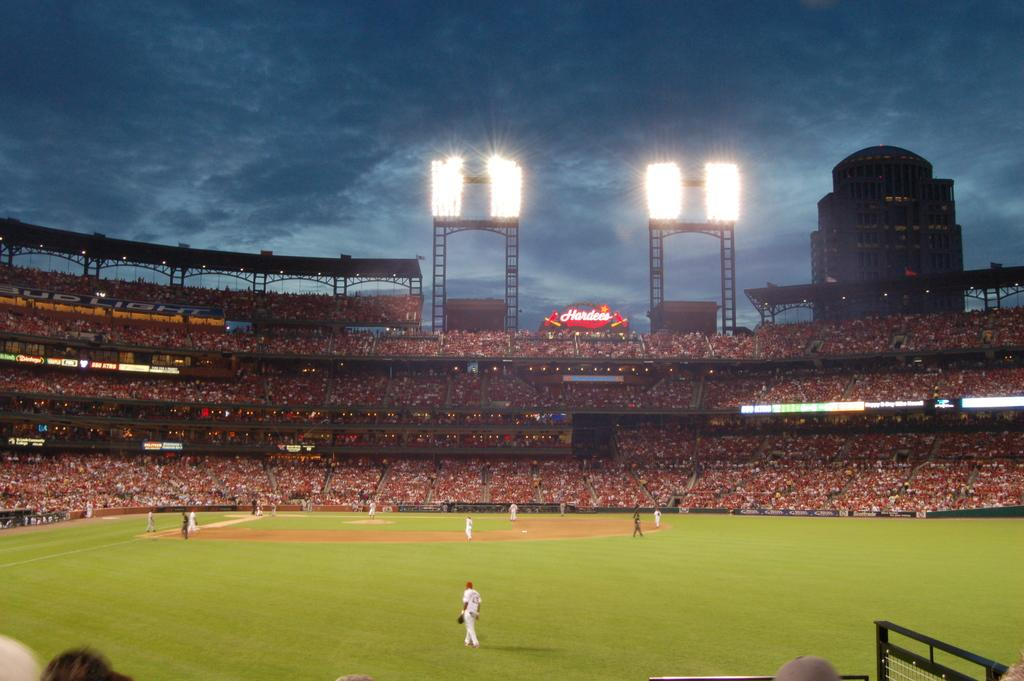How many people are in the group visible in the image? There is a group of people in the image, but the exact number is not specified. What are the people wearing in the image? The people are wearing dresses in the image. Where are the people standing in the image? The people are standing on the ground in the image. What can be seen in the background of the image? In the background of the image, there is an audience, light poles, a building, and the sky. Can you see any goldfish swimming in the image? There are no goldfish present in the image. What type of destruction can be seen happening to the building in the image? There is no destruction present in the image; the building appears to be intact. 